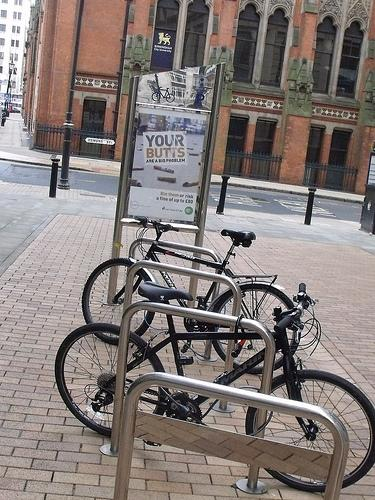Identify the main colors and objects in the scene. Black bikes, silver storage rack, cobblestone sidewalk, red brick building, black fence, and gold lion on banner. Give a quick overview of the situation depicted in the image. The situation is two parked bicycles securely chained to a storage rack on a cobblestone sidewalk in front of a red brick building. Provide a succinct description of what the image captures. Two black bikes are locked to a metallic storage rack on a cobblestone sidewalk near a red brick building and black fence. Mention the principal activity in the image. Two bikes are securely parked and chained to a storage rack on the sidewalk. State the most noticeable visual elements in the picture. Two black bikes, silver storage rack, cobblestone sidewalk, red brick building, and black metal fence. Provide a brief overview of the primary contents in the picture. The image shows two black bikes parked on a cobblestone sidewalk, chained to a silver metal storage rack, with a red brick building and black fence in the background. List some details of the objects found in the photograph. There are black bikes with black seats and handlebars, metallic storage racks, cobblestone sidewalk, red brick building, black fence, and a gold lion on a banner. Highlight the main components in the image. The primary components are two black bicycles, a metallic storage rack, a cobblestone sidewalk, a red brick building, and a black fence. In a few words, describe the setting and main objects in the image. Cobblestone sidewalk with two parked black bikes, metallic storage rack, red brick building, and black fence. What can you observe about the location and surroundings of the objects in the photo? The objects are located on a cobblestone sidewalk near a red brick building with long glass windows, a black fence is in the background, and a gold lion banner is visible. 